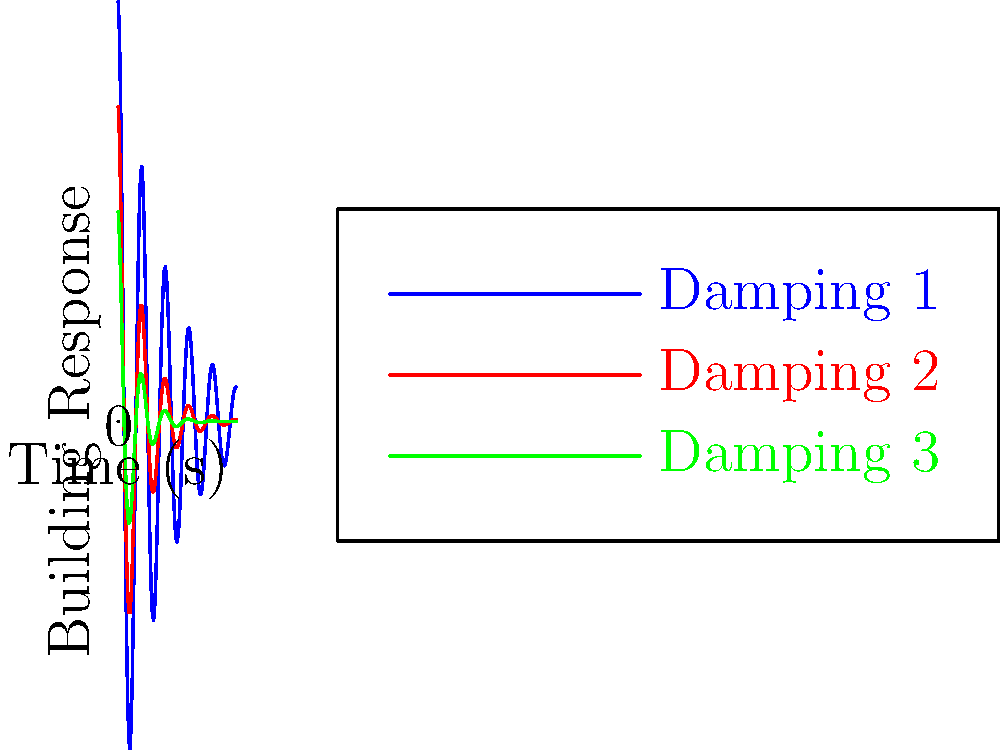The graph shows the building response over time for three different damping coefficients in a tuned mass damper system. Which damping coefficient (1, 2, or 3) provides the optimal performance for minimizing building oscillations in the event of an earthquake? To determine the optimal damping coefficient, we need to analyze the building response curves:

1. Observe the amplitude: The initial amplitude is highest for Damping 1 (blue), followed by Damping 2 (red), and lowest for Damping 3 (green).

2. Decay rate: Damping 3 (green) shows the fastest decay, followed by Damping 2 (red), and then Damping 1 (blue).

3. Oscillation period: All three curves have the same oscillation period, indicating that the natural frequency of the building remains constant.

4. Overall performance: While Damping 3 (green) has the fastest decay, it may be too aggressive, potentially reducing the system's effectiveness in dissipating energy. Damping 1 (blue) allows for too much oscillation, which could be dangerous during an earthquake.

5. Optimal balance: Damping 2 (red) provides a balance between rapid decay and effective energy dissipation. It reduces the building's response more quickly than Damping 1 but not as aggressively as Damping 3.

Therefore, Damping 2 (red) offers the optimal performance for minimizing building oscillations while maintaining effective energy dissipation during an earthquake.
Answer: Damping 2 (red curve) 